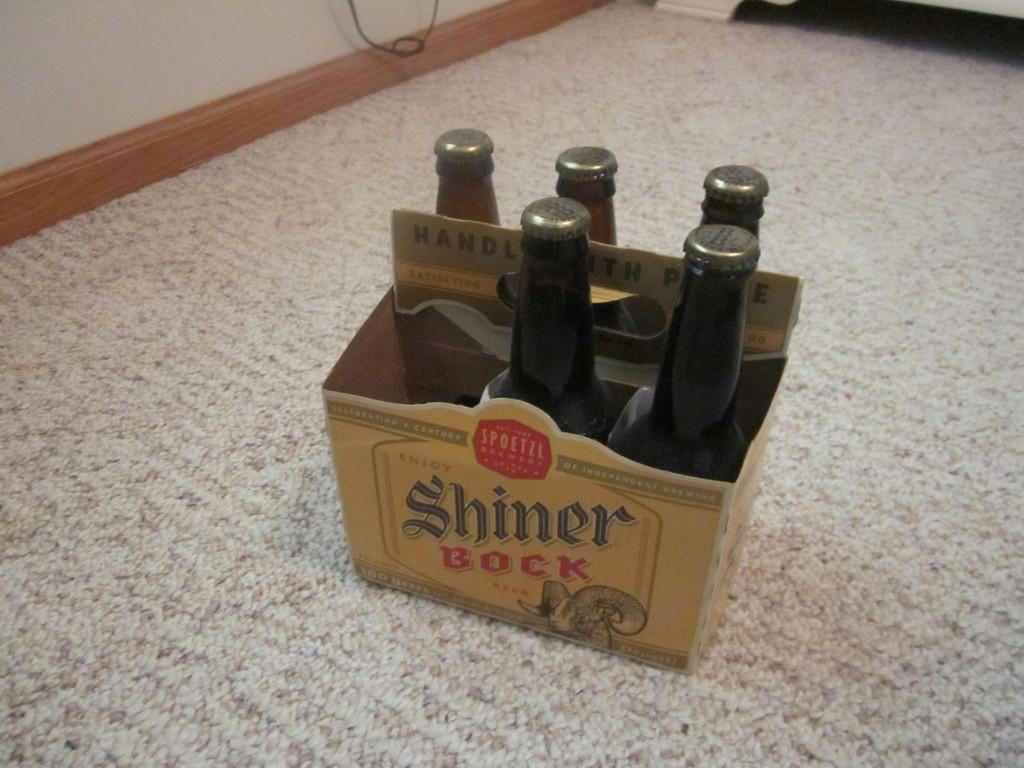<image>
Describe the image concisely. A six pack of beer made by Shiner Bock. 